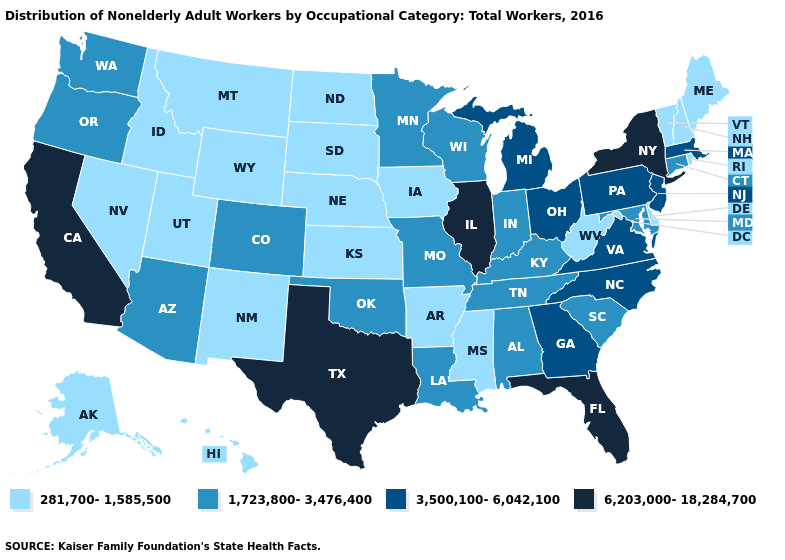What is the value of Minnesota?
Keep it brief. 1,723,800-3,476,400. Name the states that have a value in the range 281,700-1,585,500?
Concise answer only. Alaska, Arkansas, Delaware, Hawaii, Idaho, Iowa, Kansas, Maine, Mississippi, Montana, Nebraska, Nevada, New Hampshire, New Mexico, North Dakota, Rhode Island, South Dakota, Utah, Vermont, West Virginia, Wyoming. Name the states that have a value in the range 1,723,800-3,476,400?
Concise answer only. Alabama, Arizona, Colorado, Connecticut, Indiana, Kentucky, Louisiana, Maryland, Minnesota, Missouri, Oklahoma, Oregon, South Carolina, Tennessee, Washington, Wisconsin. Which states have the highest value in the USA?
Give a very brief answer. California, Florida, Illinois, New York, Texas. What is the lowest value in the Northeast?
Be succinct. 281,700-1,585,500. Name the states that have a value in the range 281,700-1,585,500?
Keep it brief. Alaska, Arkansas, Delaware, Hawaii, Idaho, Iowa, Kansas, Maine, Mississippi, Montana, Nebraska, Nevada, New Hampshire, New Mexico, North Dakota, Rhode Island, South Dakota, Utah, Vermont, West Virginia, Wyoming. Does Florida have the same value as Illinois?
Keep it brief. Yes. Does Wisconsin have the highest value in the USA?
Quick response, please. No. Among the states that border Delaware , which have the lowest value?
Be succinct. Maryland. What is the lowest value in the South?
Keep it brief. 281,700-1,585,500. Does Maryland have the lowest value in the South?
Short answer required. No. Does South Dakota have a lower value than New Mexico?
Answer briefly. No. What is the lowest value in the Northeast?
Write a very short answer. 281,700-1,585,500. What is the lowest value in the USA?
Give a very brief answer. 281,700-1,585,500. What is the value of Connecticut?
Quick response, please. 1,723,800-3,476,400. 